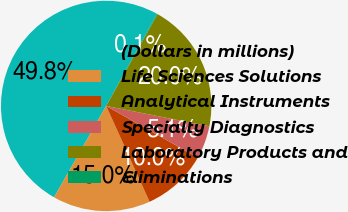<chart> <loc_0><loc_0><loc_500><loc_500><pie_chart><fcel>(Dollars in millions)<fcel>Life Sciences Solutions<fcel>Analytical Instruments<fcel>Specialty Diagnostics<fcel>Laboratory Products and<fcel>Eliminations<nl><fcel>49.77%<fcel>15.01%<fcel>10.05%<fcel>5.08%<fcel>19.98%<fcel>0.12%<nl></chart> 